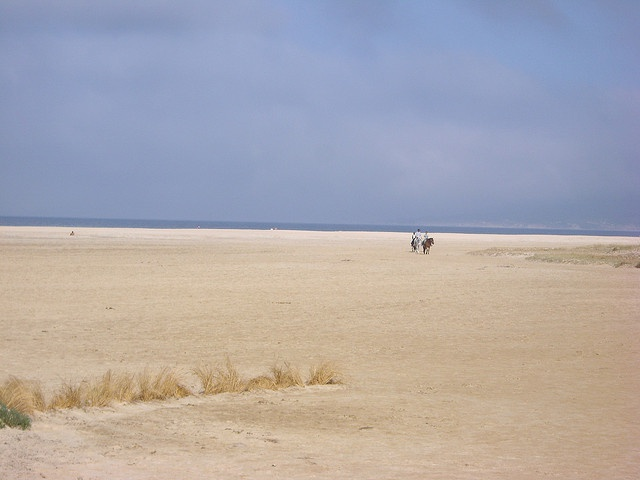Describe the objects in this image and their specific colors. I can see horse in darkgray, lightgray, and gray tones, horse in darkgray, brown, maroon, and gray tones, people in darkgray, lightgray, and gray tones, people in darkgray, lightgray, and gray tones, and people in darkgray, lightgray, black, and gray tones in this image. 